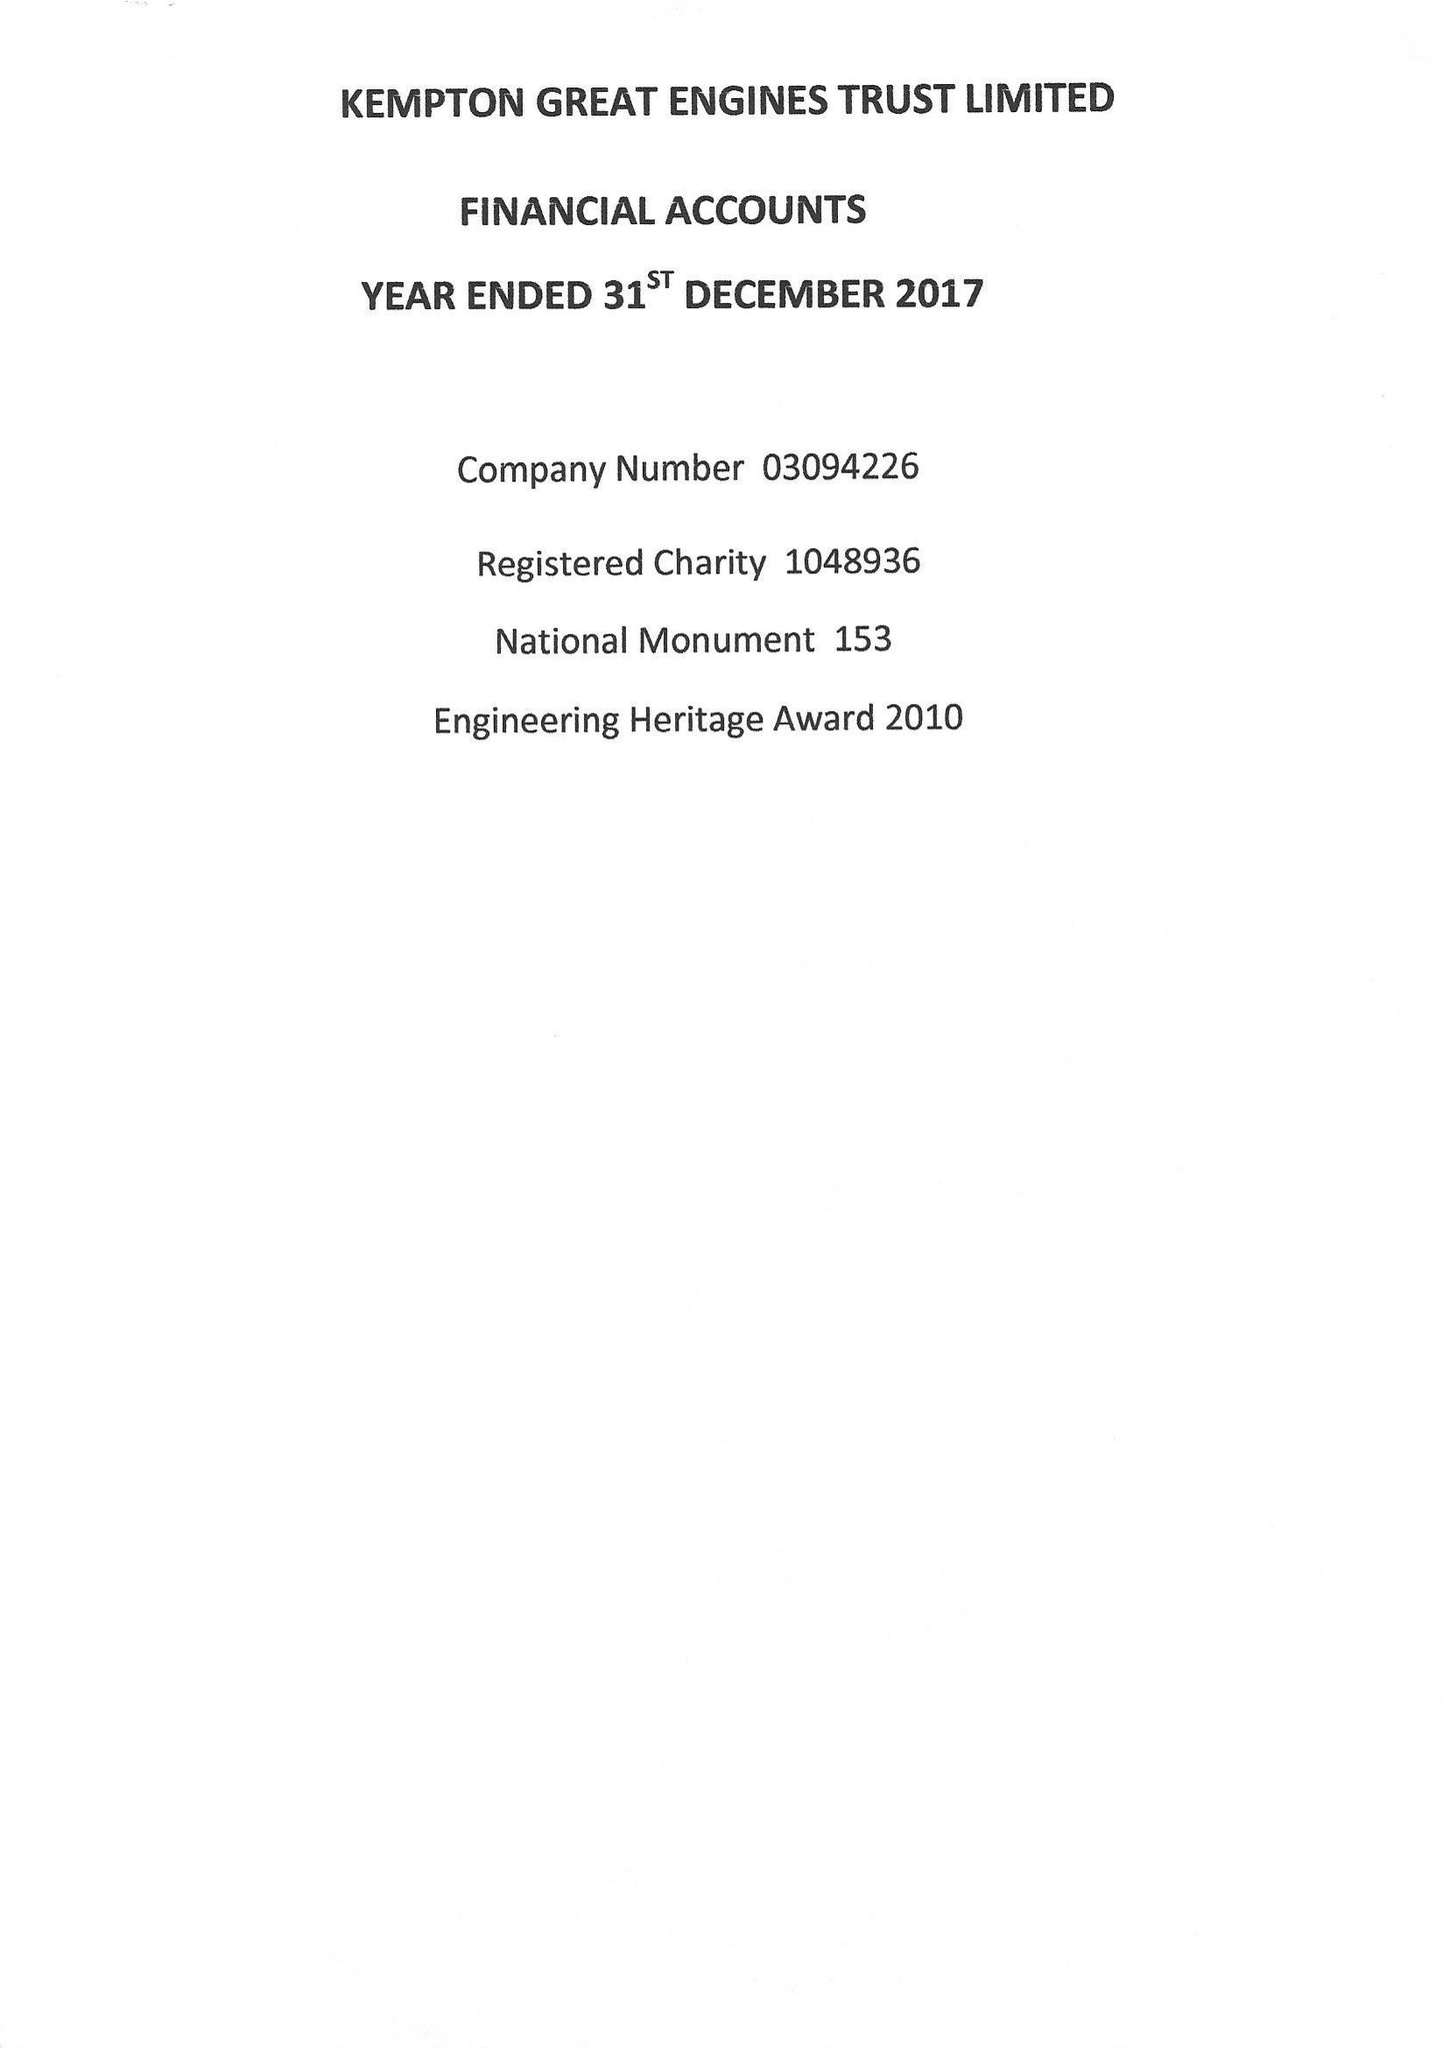What is the value for the report_date?
Answer the question using a single word or phrase. 2017-12-31 